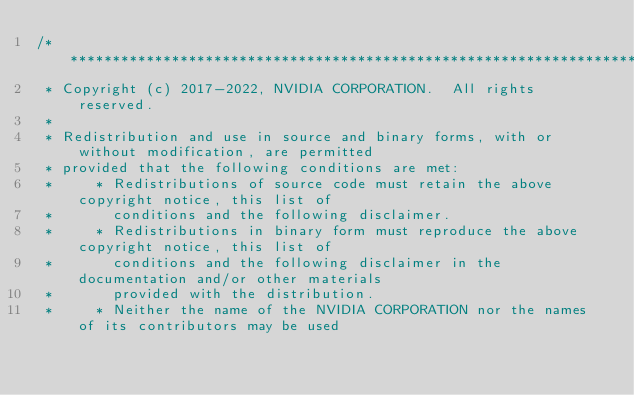<code> <loc_0><loc_0><loc_500><loc_500><_Cuda_>/***************************************************************************************************
 * Copyright (c) 2017-2022, NVIDIA CORPORATION.  All rights reserved.
 *
 * Redistribution and use in source and binary forms, with or without modification, are permitted
 * provided that the following conditions are met:
 *     * Redistributions of source code must retain the above copyright notice, this list of
 *       conditions and the following disclaimer.
 *     * Redistributions in binary form must reproduce the above copyright notice, this list of
 *       conditions and the following disclaimer in the documentation and/or other materials
 *       provided with the distribution.
 *     * Neither the name of the NVIDIA CORPORATION nor the names of its contributors may be used</code> 